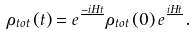Convert formula to latex. <formula><loc_0><loc_0><loc_500><loc_500>\rho _ { t o t } \left ( t \right ) = e ^ { \frac { - i H t } { } } \rho _ { t o t } \left ( 0 \right ) e ^ { \frac { i H t } { } } .</formula> 